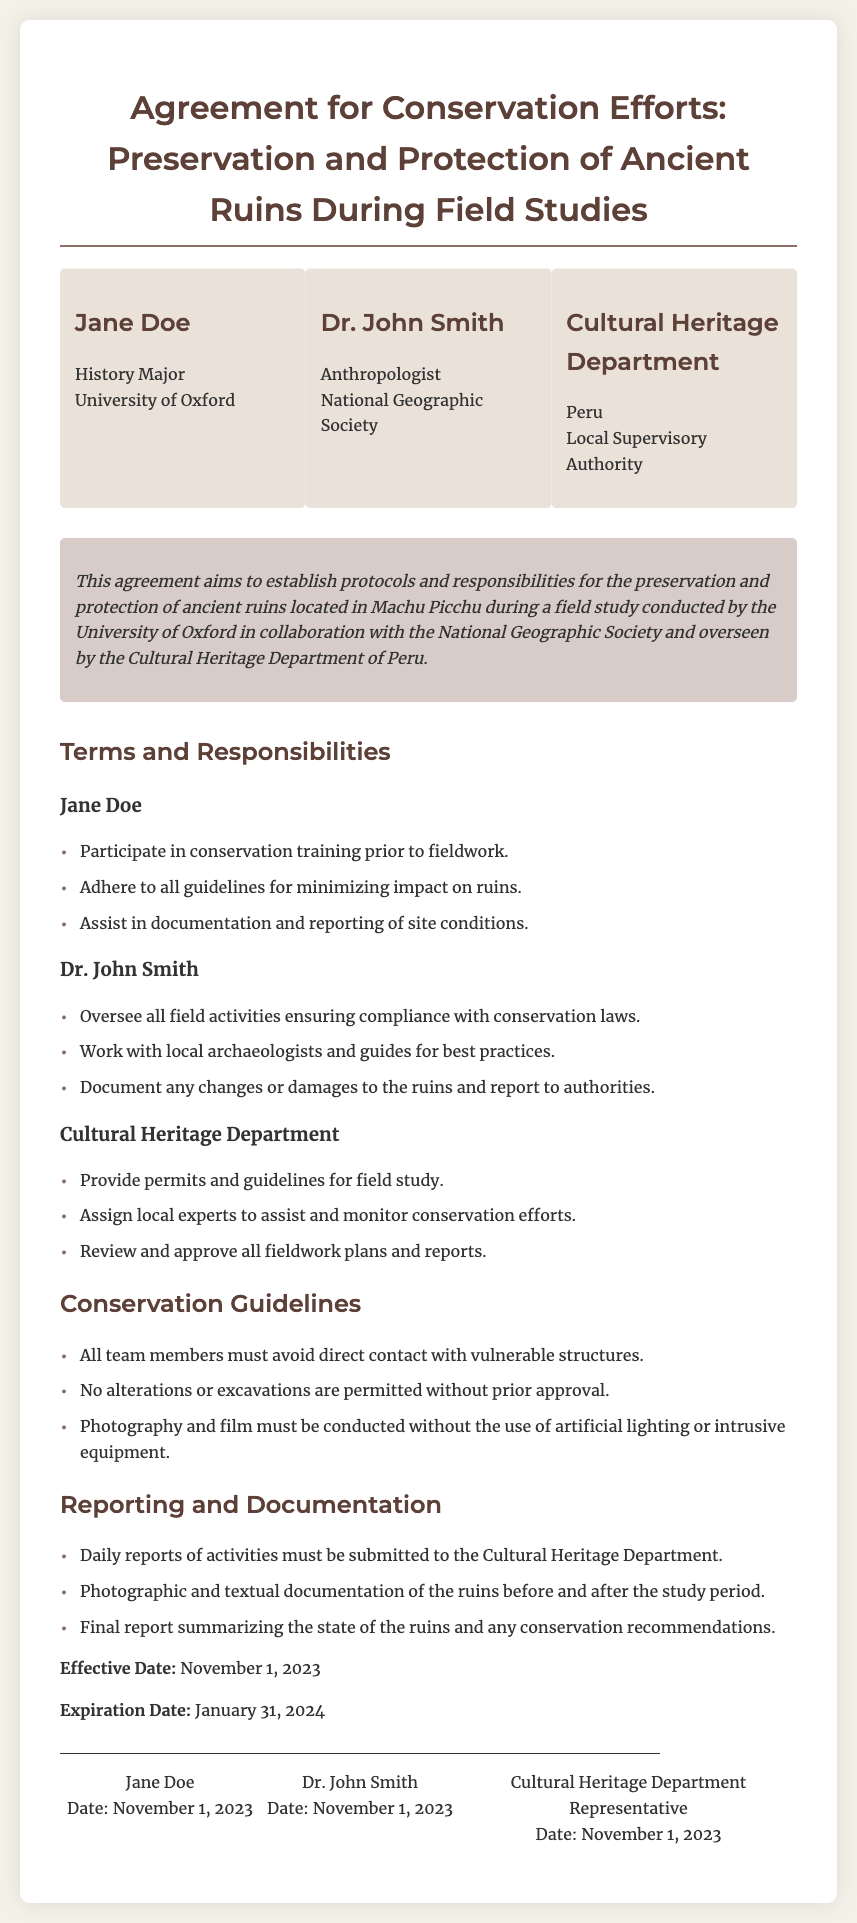What is the effective date of the agreement? The effective date is specified in the document as the date when the agreement comes into action, which is November 1, 2023.
Answer: November 1, 2023 Who is responsible for overseeing field activities? Dr. John Smith is designated to oversee all field activities as mentioned in the responsibilities section.
Answer: Dr. John Smith What is the expiration date of the agreement? The expiration date indicates when the agreement will no longer be valid, which is January 31, 2024.
Answer: January 31, 2024 What type of training must Jane Doe participate in before fieldwork? The document states that Jane Doe must participate in conservation training prior to fieldwork, indicating the importance placed on proper preparation.
Answer: Conservation training What must be submitted daily to the Cultural Heritage Department? The response outlines that daily reports of activities are necessary to keep the authorities informed and maintain accountability.
Answer: Daily reports What is one of the guidelines regarding photography? The document specifies that photography must be conducted without the use of artificial lighting or intrusive equipment.
Answer: No artificial lighting What are the parties involved in this agreement? The agreement lists three parties: Jane Doe, Dr. John Smith, and the Cultural Heritage Department of Peru, highlighting the collaborative nature of the study.
Answer: Jane Doe, Dr. John Smith, Cultural Heritage Department What should be documented before and after the study period? The document indicates that photographic and textual documentation of the ruins must be conducted before and after the study.
Answer: Photographic and textual documentation What will the cultural heritage department provide for the field study? The document specifies that the Cultural Heritage Department will provide permits and guidelines, outlining its role in facilitating the study.
Answer: Permits and guidelines 